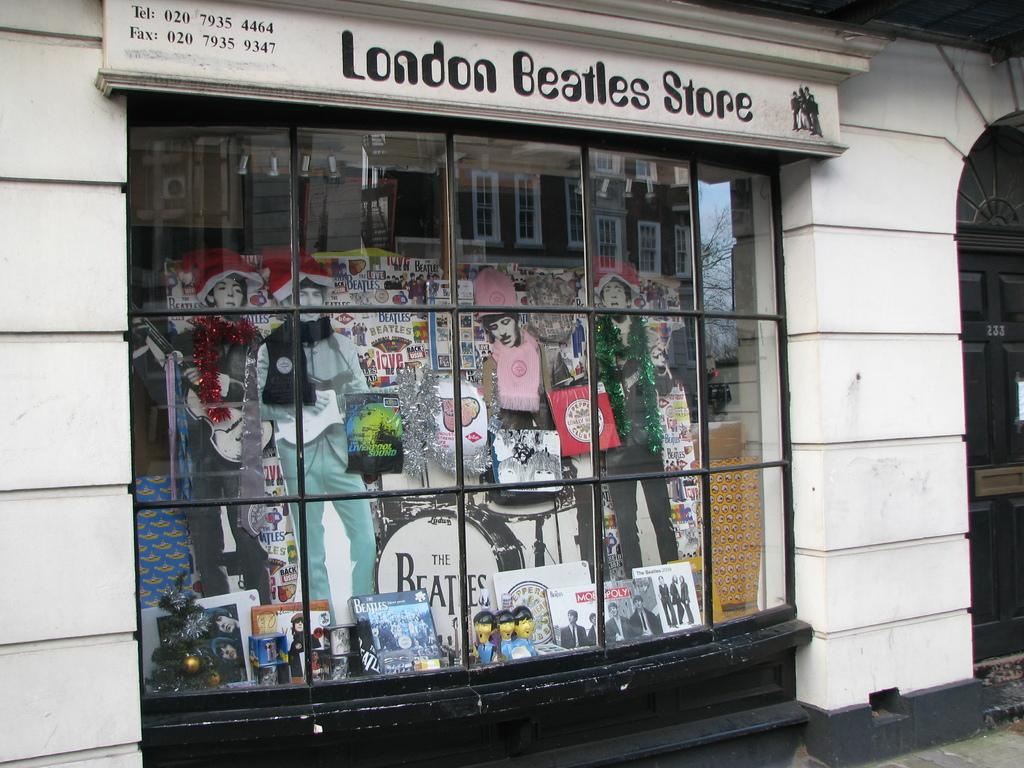What type of establishment is depicted in the image? The image shows the front view of a shop. What can be seen inside the shop? There are statues and books inside the shop. What is the name of the shop? The name of the shop is "London Beatles store". What time of day is it in the image, and is there a hill visible in the background? The time of day is not mentioned in the image, and there is no hill visible in the background. Is there an achiever inside the shop, and if so, who is it? There is no mention of an achiever or any specific person inside the shop. 